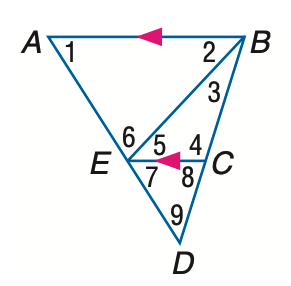Answer the mathemtical geometry problem and directly provide the correct option letter.
Question: In the figure, m \angle 1 = 58, m \angle 2 = 47, and m \angle 3 = 26. Find the measure of \angle 4.
Choices: A: 75 B: 97 C: 107 D: 117 C 